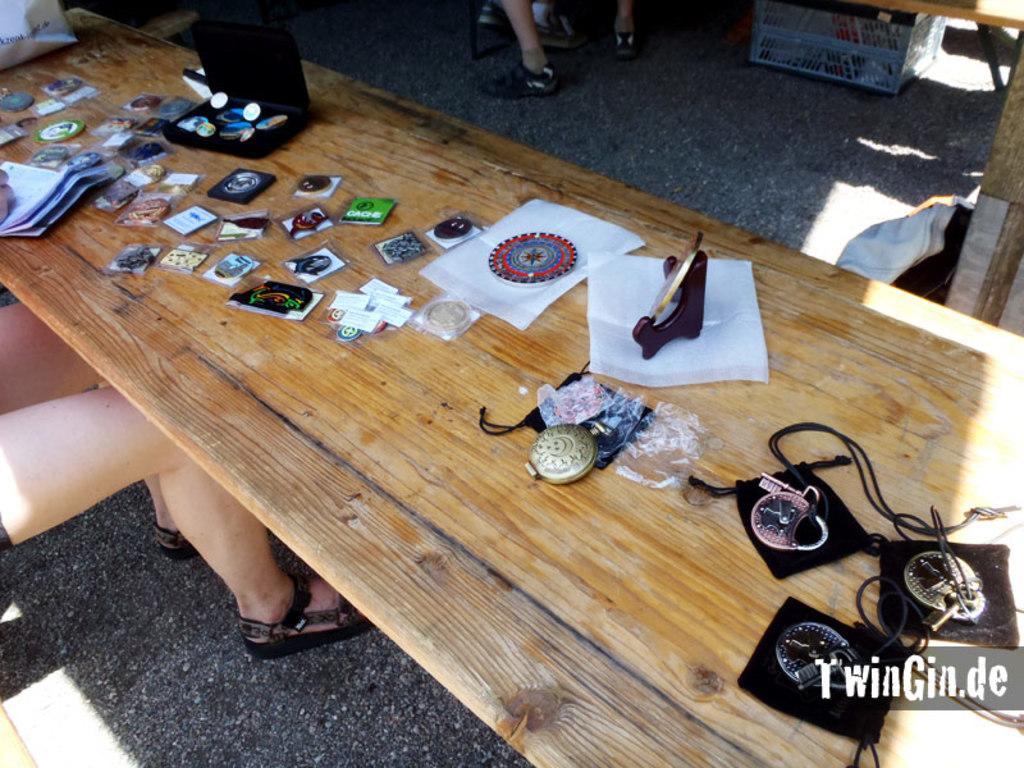How would you summarize this image in a sentence or two? In the picture we can see a wooden desk on it we can see somethings are placed and beside the desk we can see a woman sitting and behind the table we can see a person standing. 